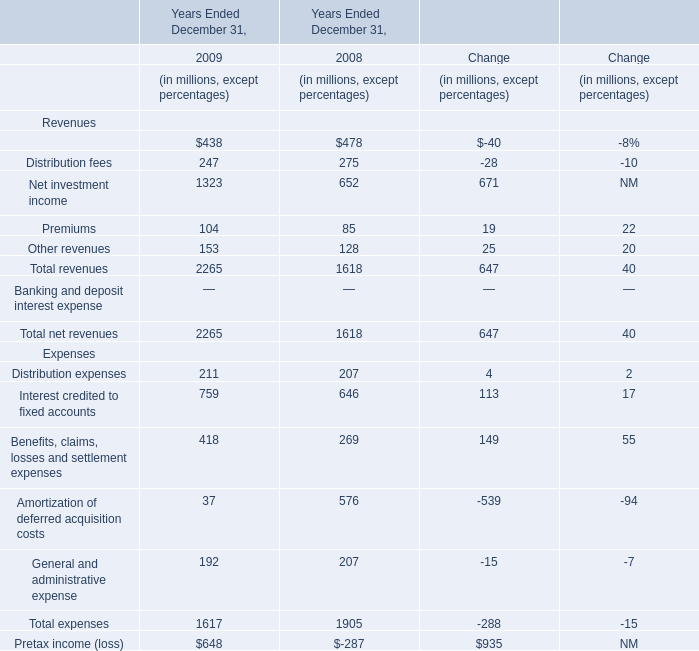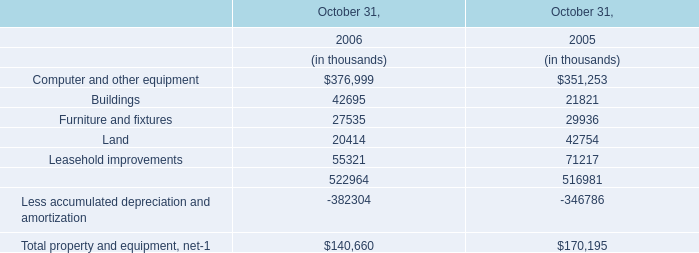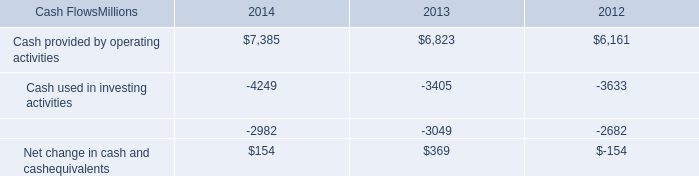what was the percentage change in cash provided by operating activities from 2012 to 2013? 
Computations: ((6823 - 6161) / 6161)
Answer: 0.10745. 